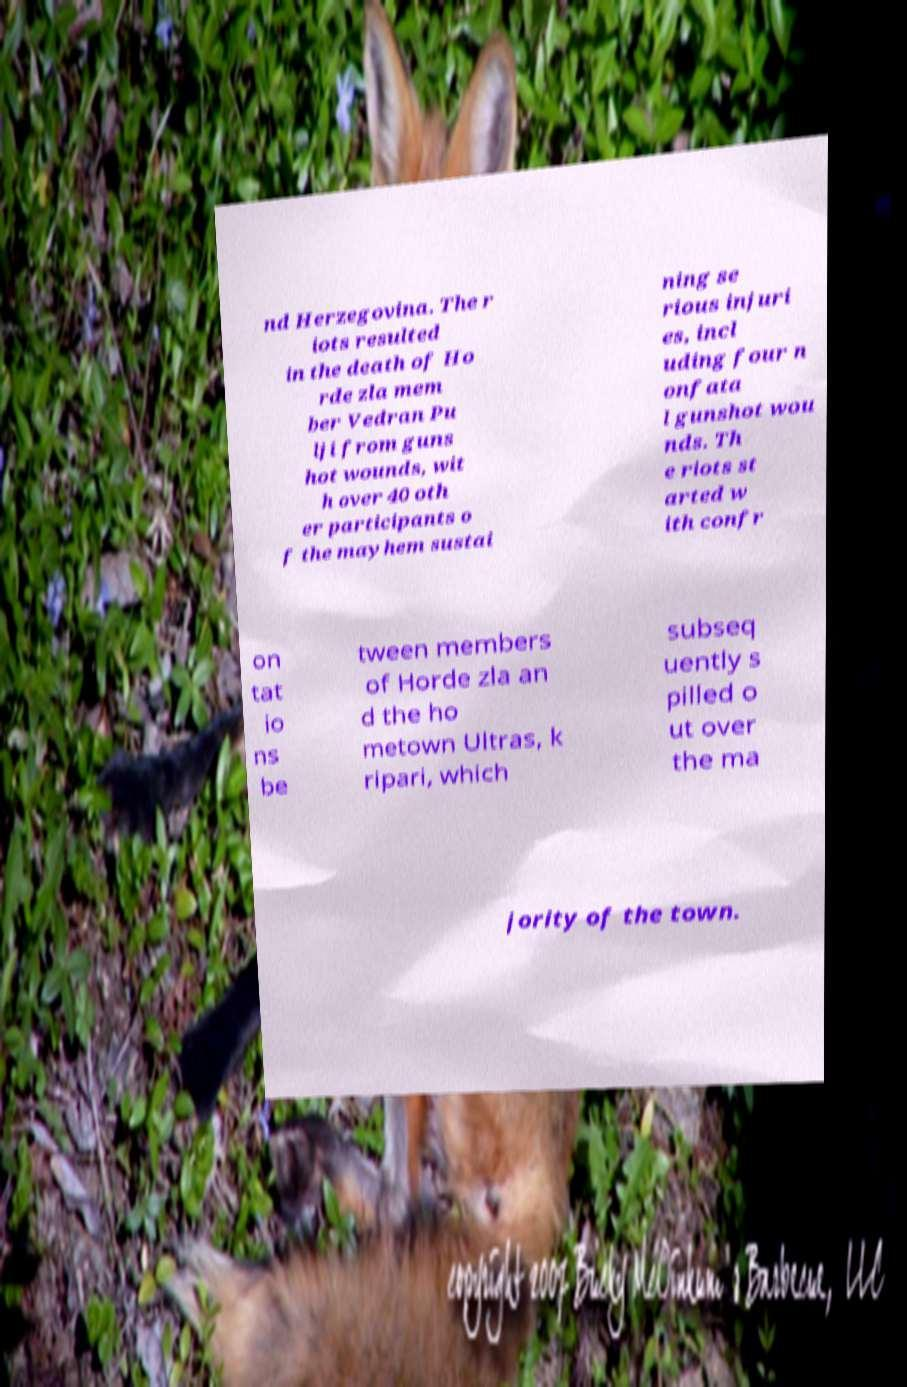Can you accurately transcribe the text from the provided image for me? nd Herzegovina. The r iots resulted in the death of Ho rde zla mem ber Vedran Pu lji from guns hot wounds, wit h over 40 oth er participants o f the mayhem sustai ning se rious injuri es, incl uding four n onfata l gunshot wou nds. Th e riots st arted w ith confr on tat io ns be tween members of Horde zla an d the ho metown Ultras, k ripari, which subseq uently s pilled o ut over the ma jority of the town. 